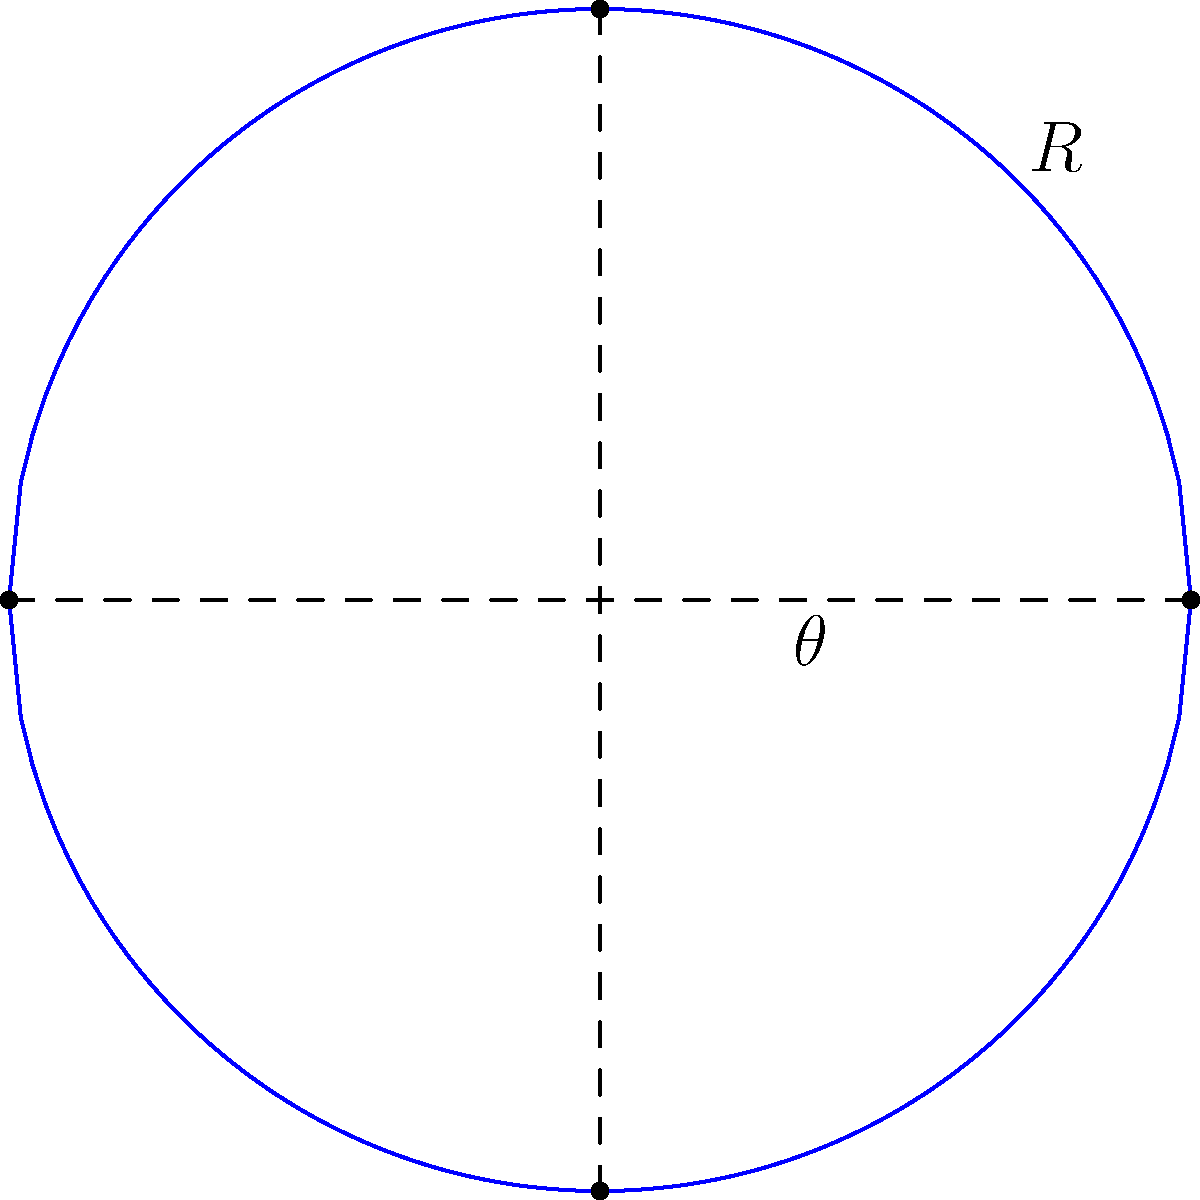Consider a simplified 2D cross-section of a Calabi-Yau manifold, represented by a unit circle in the complex plane. Given that the manifold has a characteristic radius $R$ and a quantum phase angle $\theta$, calculate the perimeter of this cross-section in terms of $R$ and $\theta$. Assume that quantum fluctuations modify the classical circumference by a factor of $\cos(\theta)$. To solve this problem, we'll follow these steps:

1) First, recall the classical formula for the circumference of a circle:
   $$C_{classical} = 2\pi R$$

2) In our quantum-modified scenario, we need to incorporate the quantum phase angle $\theta$. The problem states that quantum fluctuations modify the classical circumference by a factor of $\cos(\theta)$. Therefore, our quantum-modified circumference is:
   $$C_{quantum} = C_{classical} \cdot \cos(\theta)$$

3) Substituting the classical circumference formula:
   $$C_{quantum} = 2\pi R \cdot \cos(\theta)$$

4) This gives us the final formula for the perimeter of our Calabi-Yau manifold cross-section, taking into account both the characteristic radius $R$ and the quantum phase angle $\theta$.

5) It's worth noting that this result showcases an interesting interplay between the geometric properties of the manifold (represented by $R$) and its quantum characteristics (represented by $\theta$). This connection is a key aspect of the relationship between manifold theory and quantum mechanics in the context of Calabi-Yau manifolds.
Answer: $2\pi R \cos(\theta)$ 